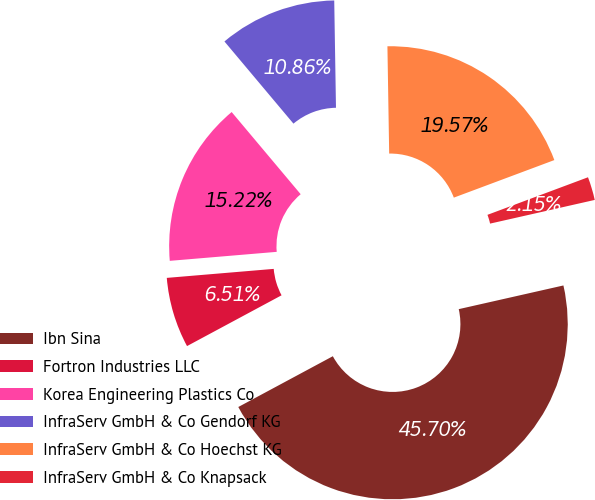<chart> <loc_0><loc_0><loc_500><loc_500><pie_chart><fcel>Ibn Sina<fcel>Fortron Industries LLC<fcel>Korea Engineering Plastics Co<fcel>InfraServ GmbH & Co Gendorf KG<fcel>InfraServ GmbH & Co Hoechst KG<fcel>InfraServ GmbH & Co Knapsack<nl><fcel>45.7%<fcel>6.51%<fcel>15.22%<fcel>10.86%<fcel>19.57%<fcel>2.15%<nl></chart> 